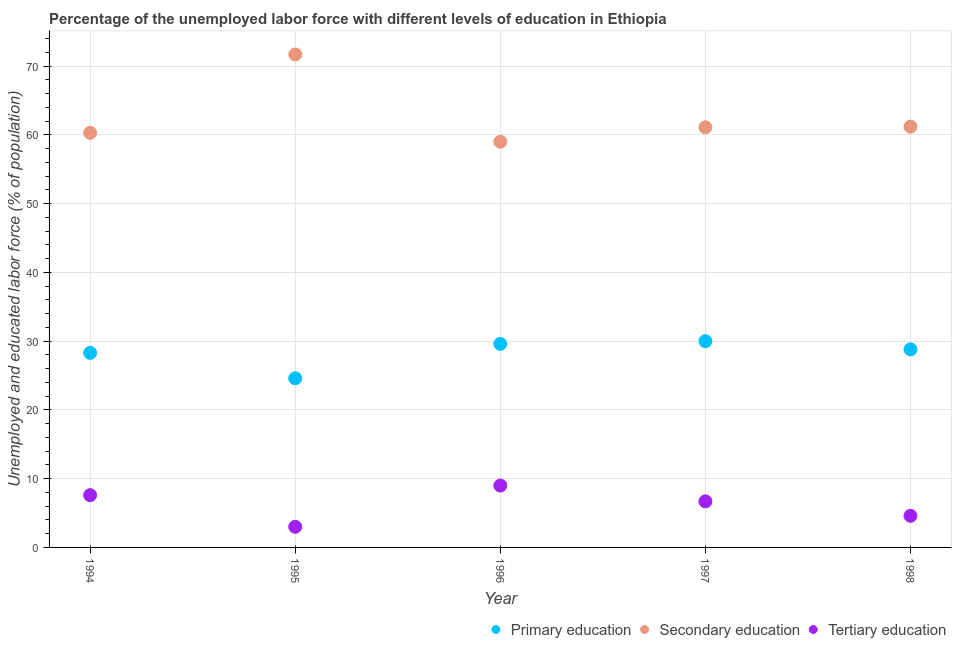Is the number of dotlines equal to the number of legend labels?
Provide a succinct answer. Yes. What is the percentage of labor force who received primary education in 1998?
Offer a terse response. 28.8. What is the total percentage of labor force who received primary education in the graph?
Provide a short and direct response. 141.3. What is the difference between the percentage of labor force who received primary education in 1996 and that in 1997?
Give a very brief answer. -0.4. What is the difference between the percentage of labor force who received primary education in 1997 and the percentage of labor force who received secondary education in 1998?
Your answer should be compact. -31.2. What is the average percentage of labor force who received secondary education per year?
Provide a short and direct response. 62.66. In the year 1996, what is the difference between the percentage of labor force who received tertiary education and percentage of labor force who received secondary education?
Give a very brief answer. -50. In how many years, is the percentage of labor force who received primary education greater than 64 %?
Your answer should be very brief. 0. What is the ratio of the percentage of labor force who received secondary education in 1994 to that in 1995?
Offer a terse response. 0.84. Is the difference between the percentage of labor force who received primary education in 1995 and 1996 greater than the difference between the percentage of labor force who received secondary education in 1995 and 1996?
Your answer should be compact. No. What is the difference between the highest and the second highest percentage of labor force who received primary education?
Your answer should be compact. 0.4. In how many years, is the percentage of labor force who received secondary education greater than the average percentage of labor force who received secondary education taken over all years?
Offer a terse response. 1. Is the sum of the percentage of labor force who received primary education in 1996 and 1998 greater than the maximum percentage of labor force who received secondary education across all years?
Offer a very short reply. No. Does the percentage of labor force who received tertiary education monotonically increase over the years?
Keep it short and to the point. No. Is the percentage of labor force who received primary education strictly less than the percentage of labor force who received secondary education over the years?
Make the answer very short. Yes. How many years are there in the graph?
Keep it short and to the point. 5. What is the difference between two consecutive major ticks on the Y-axis?
Make the answer very short. 10. Are the values on the major ticks of Y-axis written in scientific E-notation?
Your response must be concise. No. Does the graph contain grids?
Make the answer very short. Yes. Where does the legend appear in the graph?
Offer a very short reply. Bottom right. What is the title of the graph?
Provide a short and direct response. Percentage of the unemployed labor force with different levels of education in Ethiopia. Does "Labor Market" appear as one of the legend labels in the graph?
Give a very brief answer. No. What is the label or title of the X-axis?
Ensure brevity in your answer.  Year. What is the label or title of the Y-axis?
Your answer should be very brief. Unemployed and educated labor force (% of population). What is the Unemployed and educated labor force (% of population) of Primary education in 1994?
Your response must be concise. 28.3. What is the Unemployed and educated labor force (% of population) of Secondary education in 1994?
Your response must be concise. 60.3. What is the Unemployed and educated labor force (% of population) of Tertiary education in 1994?
Provide a short and direct response. 7.6. What is the Unemployed and educated labor force (% of population) of Primary education in 1995?
Your answer should be compact. 24.6. What is the Unemployed and educated labor force (% of population) of Secondary education in 1995?
Keep it short and to the point. 71.7. What is the Unemployed and educated labor force (% of population) in Primary education in 1996?
Your answer should be compact. 29.6. What is the Unemployed and educated labor force (% of population) of Tertiary education in 1996?
Provide a short and direct response. 9. What is the Unemployed and educated labor force (% of population) of Primary education in 1997?
Keep it short and to the point. 30. What is the Unemployed and educated labor force (% of population) of Secondary education in 1997?
Keep it short and to the point. 61.1. What is the Unemployed and educated labor force (% of population) of Tertiary education in 1997?
Offer a very short reply. 6.7. What is the Unemployed and educated labor force (% of population) in Primary education in 1998?
Your response must be concise. 28.8. What is the Unemployed and educated labor force (% of population) in Secondary education in 1998?
Give a very brief answer. 61.2. What is the Unemployed and educated labor force (% of population) in Tertiary education in 1998?
Offer a very short reply. 4.6. Across all years, what is the maximum Unemployed and educated labor force (% of population) in Secondary education?
Ensure brevity in your answer.  71.7. Across all years, what is the minimum Unemployed and educated labor force (% of population) of Primary education?
Your answer should be compact. 24.6. Across all years, what is the minimum Unemployed and educated labor force (% of population) of Secondary education?
Your answer should be very brief. 59. What is the total Unemployed and educated labor force (% of population) in Primary education in the graph?
Your response must be concise. 141.3. What is the total Unemployed and educated labor force (% of population) of Secondary education in the graph?
Your answer should be very brief. 313.3. What is the total Unemployed and educated labor force (% of population) in Tertiary education in the graph?
Your answer should be compact. 30.9. What is the difference between the Unemployed and educated labor force (% of population) in Primary education in 1994 and that in 1995?
Give a very brief answer. 3.7. What is the difference between the Unemployed and educated labor force (% of population) in Primary education in 1994 and that in 1996?
Keep it short and to the point. -1.3. What is the difference between the Unemployed and educated labor force (% of population) in Primary education in 1994 and that in 1997?
Give a very brief answer. -1.7. What is the difference between the Unemployed and educated labor force (% of population) of Secondary education in 1994 and that in 1997?
Your response must be concise. -0.8. What is the difference between the Unemployed and educated labor force (% of population) of Tertiary education in 1994 and that in 1997?
Give a very brief answer. 0.9. What is the difference between the Unemployed and educated labor force (% of population) of Tertiary education in 1994 and that in 1998?
Your answer should be compact. 3. What is the difference between the Unemployed and educated labor force (% of population) of Primary education in 1995 and that in 1996?
Provide a succinct answer. -5. What is the difference between the Unemployed and educated labor force (% of population) in Secondary education in 1995 and that in 1996?
Offer a terse response. 12.7. What is the difference between the Unemployed and educated labor force (% of population) in Tertiary education in 1995 and that in 1996?
Keep it short and to the point. -6. What is the difference between the Unemployed and educated labor force (% of population) in Tertiary education in 1995 and that in 1997?
Offer a terse response. -3.7. What is the difference between the Unemployed and educated labor force (% of population) in Secondary education in 1995 and that in 1998?
Your response must be concise. 10.5. What is the difference between the Unemployed and educated labor force (% of population) in Tertiary education in 1995 and that in 1998?
Offer a terse response. -1.6. What is the difference between the Unemployed and educated labor force (% of population) in Primary education in 1996 and that in 1997?
Make the answer very short. -0.4. What is the difference between the Unemployed and educated labor force (% of population) in Tertiary education in 1996 and that in 1997?
Give a very brief answer. 2.3. What is the difference between the Unemployed and educated labor force (% of population) in Secondary education in 1996 and that in 1998?
Give a very brief answer. -2.2. What is the difference between the Unemployed and educated labor force (% of population) of Primary education in 1997 and that in 1998?
Offer a very short reply. 1.2. What is the difference between the Unemployed and educated labor force (% of population) in Primary education in 1994 and the Unemployed and educated labor force (% of population) in Secondary education in 1995?
Your answer should be very brief. -43.4. What is the difference between the Unemployed and educated labor force (% of population) of Primary education in 1994 and the Unemployed and educated labor force (% of population) of Tertiary education in 1995?
Provide a short and direct response. 25.3. What is the difference between the Unemployed and educated labor force (% of population) of Secondary education in 1994 and the Unemployed and educated labor force (% of population) of Tertiary education in 1995?
Your answer should be compact. 57.3. What is the difference between the Unemployed and educated labor force (% of population) in Primary education in 1994 and the Unemployed and educated labor force (% of population) in Secondary education in 1996?
Offer a terse response. -30.7. What is the difference between the Unemployed and educated labor force (% of population) in Primary education in 1994 and the Unemployed and educated labor force (% of population) in Tertiary education in 1996?
Ensure brevity in your answer.  19.3. What is the difference between the Unemployed and educated labor force (% of population) of Secondary education in 1994 and the Unemployed and educated labor force (% of population) of Tertiary education in 1996?
Provide a succinct answer. 51.3. What is the difference between the Unemployed and educated labor force (% of population) in Primary education in 1994 and the Unemployed and educated labor force (% of population) in Secondary education in 1997?
Offer a very short reply. -32.8. What is the difference between the Unemployed and educated labor force (% of population) in Primary education in 1994 and the Unemployed and educated labor force (% of population) in Tertiary education in 1997?
Your answer should be compact. 21.6. What is the difference between the Unemployed and educated labor force (% of population) of Secondary education in 1994 and the Unemployed and educated labor force (% of population) of Tertiary education in 1997?
Make the answer very short. 53.6. What is the difference between the Unemployed and educated labor force (% of population) in Primary education in 1994 and the Unemployed and educated labor force (% of population) in Secondary education in 1998?
Make the answer very short. -32.9. What is the difference between the Unemployed and educated labor force (% of population) of Primary education in 1994 and the Unemployed and educated labor force (% of population) of Tertiary education in 1998?
Offer a very short reply. 23.7. What is the difference between the Unemployed and educated labor force (% of population) in Secondary education in 1994 and the Unemployed and educated labor force (% of population) in Tertiary education in 1998?
Your response must be concise. 55.7. What is the difference between the Unemployed and educated labor force (% of population) in Primary education in 1995 and the Unemployed and educated labor force (% of population) in Secondary education in 1996?
Your answer should be compact. -34.4. What is the difference between the Unemployed and educated labor force (% of population) of Secondary education in 1995 and the Unemployed and educated labor force (% of population) of Tertiary education in 1996?
Keep it short and to the point. 62.7. What is the difference between the Unemployed and educated labor force (% of population) of Primary education in 1995 and the Unemployed and educated labor force (% of population) of Secondary education in 1997?
Provide a succinct answer. -36.5. What is the difference between the Unemployed and educated labor force (% of population) of Primary education in 1995 and the Unemployed and educated labor force (% of population) of Secondary education in 1998?
Ensure brevity in your answer.  -36.6. What is the difference between the Unemployed and educated labor force (% of population) of Primary education in 1995 and the Unemployed and educated labor force (% of population) of Tertiary education in 1998?
Keep it short and to the point. 20. What is the difference between the Unemployed and educated labor force (% of population) of Secondary education in 1995 and the Unemployed and educated labor force (% of population) of Tertiary education in 1998?
Keep it short and to the point. 67.1. What is the difference between the Unemployed and educated labor force (% of population) of Primary education in 1996 and the Unemployed and educated labor force (% of population) of Secondary education in 1997?
Ensure brevity in your answer.  -31.5. What is the difference between the Unemployed and educated labor force (% of population) of Primary education in 1996 and the Unemployed and educated labor force (% of population) of Tertiary education in 1997?
Make the answer very short. 22.9. What is the difference between the Unemployed and educated labor force (% of population) in Secondary education in 1996 and the Unemployed and educated labor force (% of population) in Tertiary education in 1997?
Provide a succinct answer. 52.3. What is the difference between the Unemployed and educated labor force (% of population) of Primary education in 1996 and the Unemployed and educated labor force (% of population) of Secondary education in 1998?
Your response must be concise. -31.6. What is the difference between the Unemployed and educated labor force (% of population) of Primary education in 1996 and the Unemployed and educated labor force (% of population) of Tertiary education in 1998?
Your response must be concise. 25. What is the difference between the Unemployed and educated labor force (% of population) of Secondary education in 1996 and the Unemployed and educated labor force (% of population) of Tertiary education in 1998?
Offer a terse response. 54.4. What is the difference between the Unemployed and educated labor force (% of population) in Primary education in 1997 and the Unemployed and educated labor force (% of population) in Secondary education in 1998?
Offer a very short reply. -31.2. What is the difference between the Unemployed and educated labor force (% of population) in Primary education in 1997 and the Unemployed and educated labor force (% of population) in Tertiary education in 1998?
Keep it short and to the point. 25.4. What is the difference between the Unemployed and educated labor force (% of population) of Secondary education in 1997 and the Unemployed and educated labor force (% of population) of Tertiary education in 1998?
Offer a very short reply. 56.5. What is the average Unemployed and educated labor force (% of population) in Primary education per year?
Your response must be concise. 28.26. What is the average Unemployed and educated labor force (% of population) in Secondary education per year?
Make the answer very short. 62.66. What is the average Unemployed and educated labor force (% of population) of Tertiary education per year?
Your answer should be very brief. 6.18. In the year 1994, what is the difference between the Unemployed and educated labor force (% of population) of Primary education and Unemployed and educated labor force (% of population) of Secondary education?
Make the answer very short. -32. In the year 1994, what is the difference between the Unemployed and educated labor force (% of population) of Primary education and Unemployed and educated labor force (% of population) of Tertiary education?
Make the answer very short. 20.7. In the year 1994, what is the difference between the Unemployed and educated labor force (% of population) in Secondary education and Unemployed and educated labor force (% of population) in Tertiary education?
Ensure brevity in your answer.  52.7. In the year 1995, what is the difference between the Unemployed and educated labor force (% of population) in Primary education and Unemployed and educated labor force (% of population) in Secondary education?
Give a very brief answer. -47.1. In the year 1995, what is the difference between the Unemployed and educated labor force (% of population) in Primary education and Unemployed and educated labor force (% of population) in Tertiary education?
Provide a short and direct response. 21.6. In the year 1995, what is the difference between the Unemployed and educated labor force (% of population) of Secondary education and Unemployed and educated labor force (% of population) of Tertiary education?
Give a very brief answer. 68.7. In the year 1996, what is the difference between the Unemployed and educated labor force (% of population) in Primary education and Unemployed and educated labor force (% of population) in Secondary education?
Ensure brevity in your answer.  -29.4. In the year 1996, what is the difference between the Unemployed and educated labor force (% of population) in Primary education and Unemployed and educated labor force (% of population) in Tertiary education?
Give a very brief answer. 20.6. In the year 1996, what is the difference between the Unemployed and educated labor force (% of population) in Secondary education and Unemployed and educated labor force (% of population) in Tertiary education?
Ensure brevity in your answer.  50. In the year 1997, what is the difference between the Unemployed and educated labor force (% of population) in Primary education and Unemployed and educated labor force (% of population) in Secondary education?
Provide a short and direct response. -31.1. In the year 1997, what is the difference between the Unemployed and educated labor force (% of population) of Primary education and Unemployed and educated labor force (% of population) of Tertiary education?
Provide a short and direct response. 23.3. In the year 1997, what is the difference between the Unemployed and educated labor force (% of population) in Secondary education and Unemployed and educated labor force (% of population) in Tertiary education?
Give a very brief answer. 54.4. In the year 1998, what is the difference between the Unemployed and educated labor force (% of population) of Primary education and Unemployed and educated labor force (% of population) of Secondary education?
Provide a succinct answer. -32.4. In the year 1998, what is the difference between the Unemployed and educated labor force (% of population) of Primary education and Unemployed and educated labor force (% of population) of Tertiary education?
Ensure brevity in your answer.  24.2. In the year 1998, what is the difference between the Unemployed and educated labor force (% of population) of Secondary education and Unemployed and educated labor force (% of population) of Tertiary education?
Offer a terse response. 56.6. What is the ratio of the Unemployed and educated labor force (% of population) of Primary education in 1994 to that in 1995?
Give a very brief answer. 1.15. What is the ratio of the Unemployed and educated labor force (% of population) of Secondary education in 1994 to that in 1995?
Keep it short and to the point. 0.84. What is the ratio of the Unemployed and educated labor force (% of population) in Tertiary education in 1994 to that in 1995?
Keep it short and to the point. 2.53. What is the ratio of the Unemployed and educated labor force (% of population) of Primary education in 1994 to that in 1996?
Give a very brief answer. 0.96. What is the ratio of the Unemployed and educated labor force (% of population) of Secondary education in 1994 to that in 1996?
Your response must be concise. 1.02. What is the ratio of the Unemployed and educated labor force (% of population) in Tertiary education in 1994 to that in 1996?
Ensure brevity in your answer.  0.84. What is the ratio of the Unemployed and educated labor force (% of population) of Primary education in 1994 to that in 1997?
Offer a terse response. 0.94. What is the ratio of the Unemployed and educated labor force (% of population) of Secondary education in 1994 to that in 1997?
Give a very brief answer. 0.99. What is the ratio of the Unemployed and educated labor force (% of population) of Tertiary education in 1994 to that in 1997?
Keep it short and to the point. 1.13. What is the ratio of the Unemployed and educated labor force (% of population) in Primary education in 1994 to that in 1998?
Offer a very short reply. 0.98. What is the ratio of the Unemployed and educated labor force (% of population) in Tertiary education in 1994 to that in 1998?
Make the answer very short. 1.65. What is the ratio of the Unemployed and educated labor force (% of population) in Primary education in 1995 to that in 1996?
Offer a terse response. 0.83. What is the ratio of the Unemployed and educated labor force (% of population) in Secondary education in 1995 to that in 1996?
Provide a short and direct response. 1.22. What is the ratio of the Unemployed and educated labor force (% of population) of Primary education in 1995 to that in 1997?
Your answer should be very brief. 0.82. What is the ratio of the Unemployed and educated labor force (% of population) of Secondary education in 1995 to that in 1997?
Provide a succinct answer. 1.17. What is the ratio of the Unemployed and educated labor force (% of population) of Tertiary education in 1995 to that in 1997?
Make the answer very short. 0.45. What is the ratio of the Unemployed and educated labor force (% of population) of Primary education in 1995 to that in 1998?
Your answer should be very brief. 0.85. What is the ratio of the Unemployed and educated labor force (% of population) in Secondary education in 1995 to that in 1998?
Keep it short and to the point. 1.17. What is the ratio of the Unemployed and educated labor force (% of population) of Tertiary education in 1995 to that in 1998?
Ensure brevity in your answer.  0.65. What is the ratio of the Unemployed and educated labor force (% of population) in Primary education in 1996 to that in 1997?
Provide a succinct answer. 0.99. What is the ratio of the Unemployed and educated labor force (% of population) of Secondary education in 1996 to that in 1997?
Ensure brevity in your answer.  0.97. What is the ratio of the Unemployed and educated labor force (% of population) in Tertiary education in 1996 to that in 1997?
Make the answer very short. 1.34. What is the ratio of the Unemployed and educated labor force (% of population) in Primary education in 1996 to that in 1998?
Keep it short and to the point. 1.03. What is the ratio of the Unemployed and educated labor force (% of population) of Secondary education in 1996 to that in 1998?
Provide a short and direct response. 0.96. What is the ratio of the Unemployed and educated labor force (% of population) in Tertiary education in 1996 to that in 1998?
Your answer should be very brief. 1.96. What is the ratio of the Unemployed and educated labor force (% of population) in Primary education in 1997 to that in 1998?
Provide a succinct answer. 1.04. What is the ratio of the Unemployed and educated labor force (% of population) in Secondary education in 1997 to that in 1998?
Keep it short and to the point. 1. What is the ratio of the Unemployed and educated labor force (% of population) of Tertiary education in 1997 to that in 1998?
Give a very brief answer. 1.46. What is the difference between the highest and the second highest Unemployed and educated labor force (% of population) of Primary education?
Give a very brief answer. 0.4. What is the difference between the highest and the second highest Unemployed and educated labor force (% of population) of Tertiary education?
Your response must be concise. 1.4. What is the difference between the highest and the lowest Unemployed and educated labor force (% of population) of Secondary education?
Offer a terse response. 12.7. 